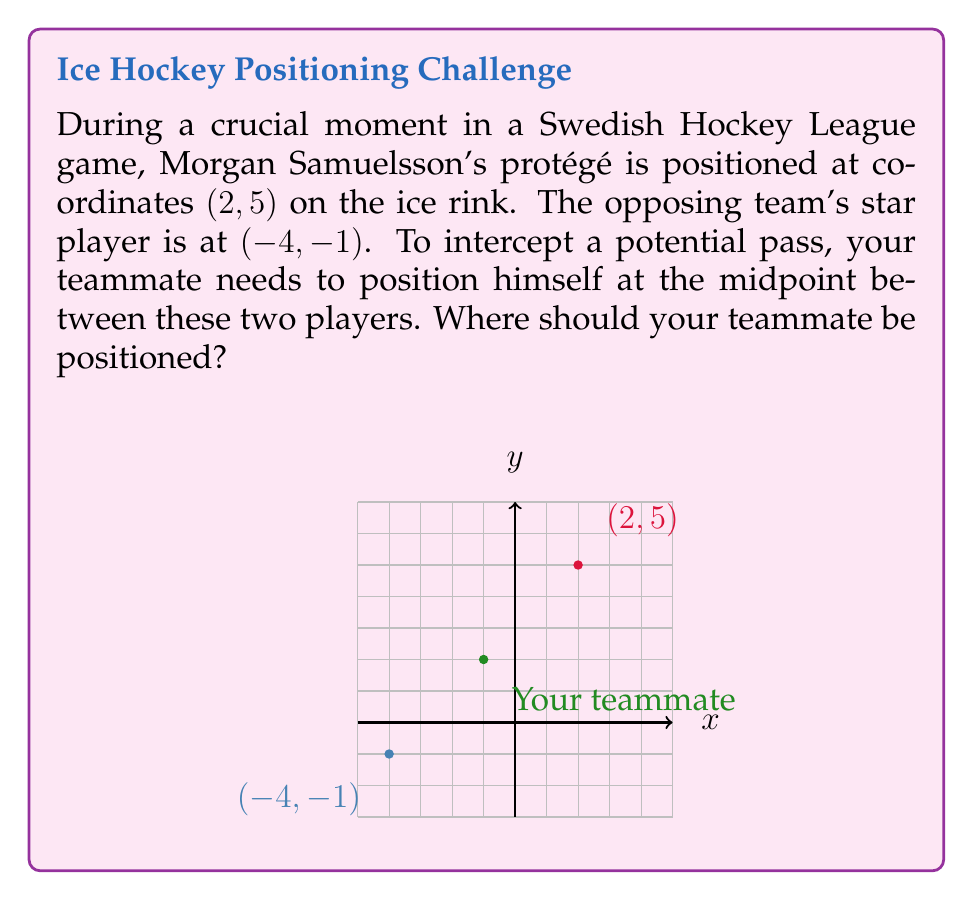Could you help me with this problem? To find the midpoint between two points, we use the midpoint formula:

$$ \text{Midpoint} = \left(\frac{x_1 + x_2}{2}, \frac{y_1 + y_2}{2}\right) $$

Where $(x_1, y_1)$ is the position of Morgan Samuelsson's protégé and $(x_2, y_2)$ is the position of the opposing player.

Step 1: Identify the coordinates
- Morgan Samuelsson's protégé: $(x_1, y_1) = (2, 5)$
- Opposing player: $(x_2, y_2) = (-4, -1)$

Step 2: Apply the midpoint formula
$$ x = \frac{x_1 + x_2}{2} = \frac{2 + (-4)}{2} = \frac{-2}{2} = -1 $$
$$ y = \frac{y_1 + y_2}{2} = \frac{5 + (-1)}{2} = \frac{4}{2} = 2 $$

Therefore, the midpoint coordinates are $(-1, 2)$.
Answer: $(-1, 2)$ 